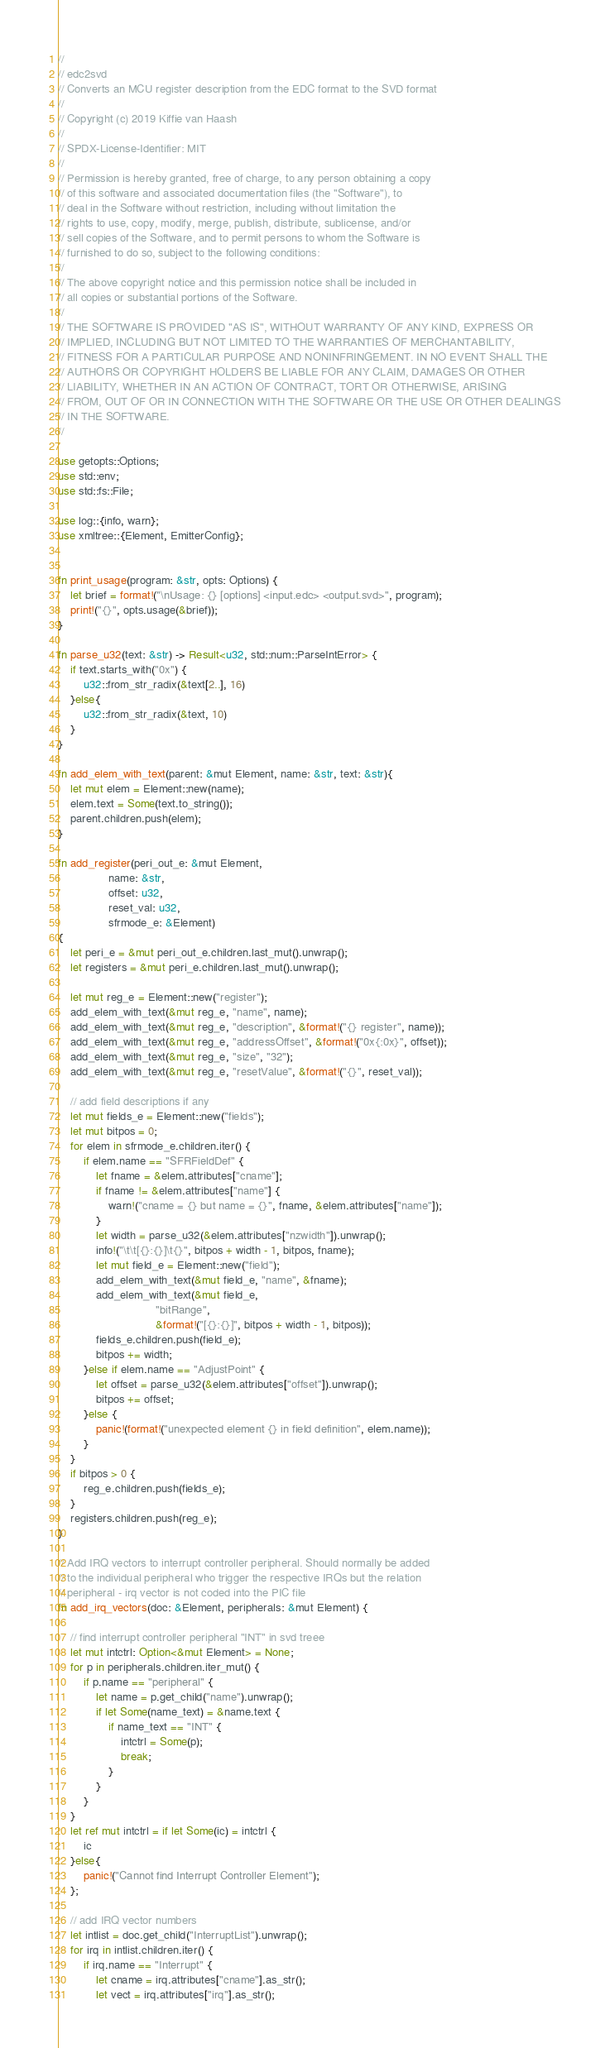<code> <loc_0><loc_0><loc_500><loc_500><_Rust_>//
// edc2svd
// Converts an MCU register description from the EDC format to the SVD format
//
// Copyright (c) 2019 Kiffie van Haash
//
// SPDX-License-Identifier: MIT
//
// Permission is hereby granted, free of charge, to any person obtaining a copy
// of this software and associated documentation files (the "Software"), to
// deal in the Software without restriction, including without limitation the
// rights to use, copy, modify, merge, publish, distribute, sublicense, and/or
// sell copies of the Software, and to permit persons to whom the Software is
// furnished to do so, subject to the following conditions:
//
// The above copyright notice and this permission notice shall be included in
// all copies or substantial portions of the Software.
//
// THE SOFTWARE IS PROVIDED "AS IS", WITHOUT WARRANTY OF ANY KIND, EXPRESS OR
// IMPLIED, INCLUDING BUT NOT LIMITED TO THE WARRANTIES OF MERCHANTABILITY,
// FITNESS FOR A PARTICULAR PURPOSE AND NONINFRINGEMENT. IN NO EVENT SHALL THE
// AUTHORS OR COPYRIGHT HOLDERS BE LIABLE FOR ANY CLAIM, DAMAGES OR OTHER
// LIABILITY, WHETHER IN AN ACTION OF CONTRACT, TORT OR OTHERWISE, ARISING
// FROM, OUT OF OR IN CONNECTION WITH THE SOFTWARE OR THE USE OR OTHER DEALINGS
// IN THE SOFTWARE.
//

use getopts::Options;
use std::env;
use std::fs::File;

use log::{info, warn};
use xmltree::{Element, EmitterConfig};


fn print_usage(program: &str, opts: Options) {
    let brief = format!("\nUsage: {} [options] <input.edc> <output.svd>", program);
    print!("{}", opts.usage(&brief));
}

fn parse_u32(text: &str) -> Result<u32, std::num::ParseIntError> {
    if text.starts_with("0x") {
        u32::from_str_radix(&text[2..], 16)
    }else{
        u32::from_str_radix(&text, 10)
    }
}

fn add_elem_with_text(parent: &mut Element, name: &str, text: &str){
    let mut elem = Element::new(name);
    elem.text = Some(text.to_string());
    parent.children.push(elem);
}

fn add_register(peri_out_e: &mut Element,
                name: &str,
                offset: u32,
                reset_val: u32,
                sfrmode_e: &Element)
{
    let peri_e = &mut peri_out_e.children.last_mut().unwrap();
    let registers = &mut peri_e.children.last_mut().unwrap();

    let mut reg_e = Element::new("register");
    add_elem_with_text(&mut reg_e, "name", name);
    add_elem_with_text(&mut reg_e, "description", &format!("{} register", name));
    add_elem_with_text(&mut reg_e, "addressOffset", &format!("0x{:0x}", offset));
    add_elem_with_text(&mut reg_e, "size", "32");
    add_elem_with_text(&mut reg_e, "resetValue", &format!("{}", reset_val));

    // add field descriptions if any
    let mut fields_e = Element::new("fields");
    let mut bitpos = 0;
    for elem in sfrmode_e.children.iter() {
        if elem.name == "SFRFieldDef" {
            let fname = &elem.attributes["cname"];
            if fname != &elem.attributes["name"] {
                warn!("cname = {} but name = {}", fname, &elem.attributes["name"]);
            }
            let width = parse_u32(&elem.attributes["nzwidth"]).unwrap();
            info!("\t\t[{}:{}]\t{}", bitpos + width - 1, bitpos, fname);
            let mut field_e = Element::new("field");
            add_elem_with_text(&mut field_e, "name", &fname);
            add_elem_with_text(&mut field_e,
                               "bitRange",
                               &format!("[{}:{}]", bitpos + width - 1, bitpos));
            fields_e.children.push(field_e);
            bitpos += width;
        }else if elem.name == "AdjustPoint" {
            let offset = parse_u32(&elem.attributes["offset"]).unwrap();
            bitpos += offset;
        }else {
            panic!(format!("unexpected element {} in field definition", elem.name));
        }
    }
    if bitpos > 0 {
        reg_e.children.push(fields_e);
    }
    registers.children.push(reg_e);
}

// Add IRQ vectors to interrupt controller peripheral. Should normally be added
// to the individual peripheral who trigger the respective IRQs but the relation
// peripheral - irq vector is not coded into the PIC file
fn add_irq_vectors(doc: &Element, peripherals: &mut Element) {

    // find interrupt controller peripheral "INT" in svd treee
    let mut intctrl: Option<&mut Element> = None;
    for p in peripherals.children.iter_mut() {
        if p.name == "peripheral" {
            let name = p.get_child("name").unwrap();
            if let Some(name_text) = &name.text {
                if name_text == "INT" {
                    intctrl = Some(p);
                    break;
                }
            }
        }
    }
    let ref mut intctrl = if let Some(ic) = intctrl {
        ic
    }else{
        panic!("Cannot find Interrupt Controller Element");
    };

    // add IRQ vector numbers
    let intlist = doc.get_child("InterruptList").unwrap();
    for irq in intlist.children.iter() {
        if irq.name == "Interrupt" {
            let cname = irq.attributes["cname"].as_str();
            let vect = irq.attributes["irq"].as_str();</code> 